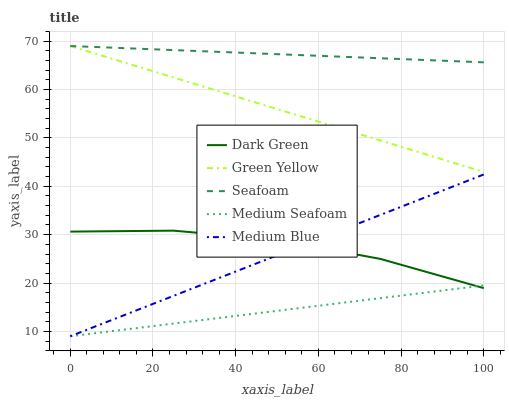Does Green Yellow have the minimum area under the curve?
Answer yes or no. No. Does Green Yellow have the maximum area under the curve?
Answer yes or no. No. Is Green Yellow the smoothest?
Answer yes or no. No. Is Green Yellow the roughest?
Answer yes or no. No. Does Green Yellow have the lowest value?
Answer yes or no. No. Does Medium Blue have the highest value?
Answer yes or no. No. Is Medium Blue less than Green Yellow?
Answer yes or no. Yes. Is Green Yellow greater than Medium Blue?
Answer yes or no. Yes. Does Medium Blue intersect Green Yellow?
Answer yes or no. No. 